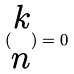<formula> <loc_0><loc_0><loc_500><loc_500>( \begin{matrix} k \\ n \end{matrix} ) = 0</formula> 